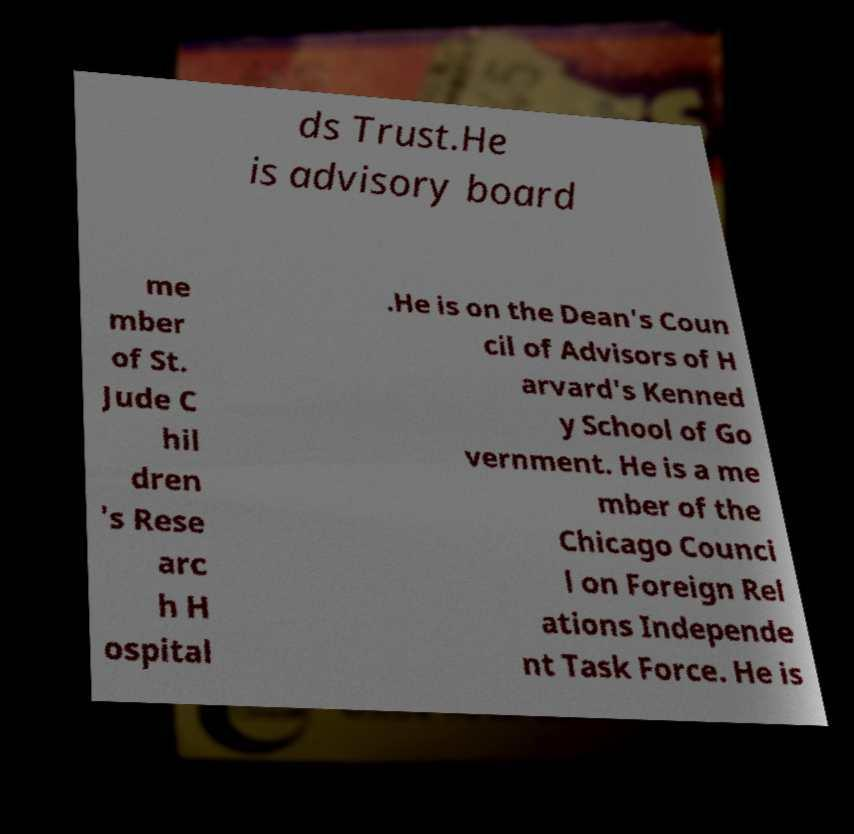There's text embedded in this image that I need extracted. Can you transcribe it verbatim? ds Trust.He is advisory board me mber of St. Jude C hil dren 's Rese arc h H ospital .He is on the Dean's Coun cil of Advisors of H arvard's Kenned y School of Go vernment. He is a me mber of the Chicago Counci l on Foreign Rel ations Independe nt Task Force. He is 